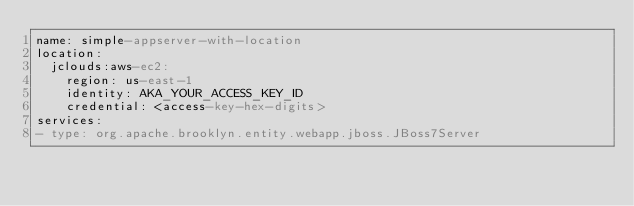Convert code to text. <code><loc_0><loc_0><loc_500><loc_500><_YAML_>name: simple-appserver-with-location
location:
  jclouds:aws-ec2:
    region: us-east-1
    identity: AKA_YOUR_ACCESS_KEY_ID
    credential: <access-key-hex-digits>
services:
- type: org.apache.brooklyn.entity.webapp.jboss.JBoss7Server
</code> 